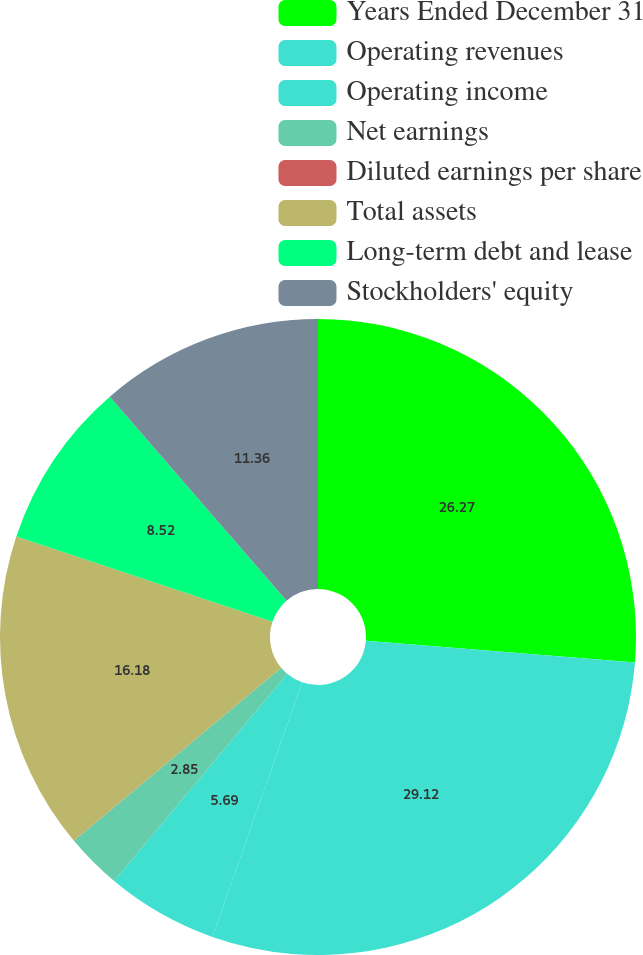Convert chart to OTSL. <chart><loc_0><loc_0><loc_500><loc_500><pie_chart><fcel>Years Ended December 31<fcel>Operating revenues<fcel>Operating income<fcel>Net earnings<fcel>Diluted earnings per share<fcel>Total assets<fcel>Long-term debt and lease<fcel>Stockholders' equity<nl><fcel>26.27%<fcel>29.11%<fcel>5.69%<fcel>2.85%<fcel>0.01%<fcel>16.18%<fcel>8.52%<fcel>11.36%<nl></chart> 